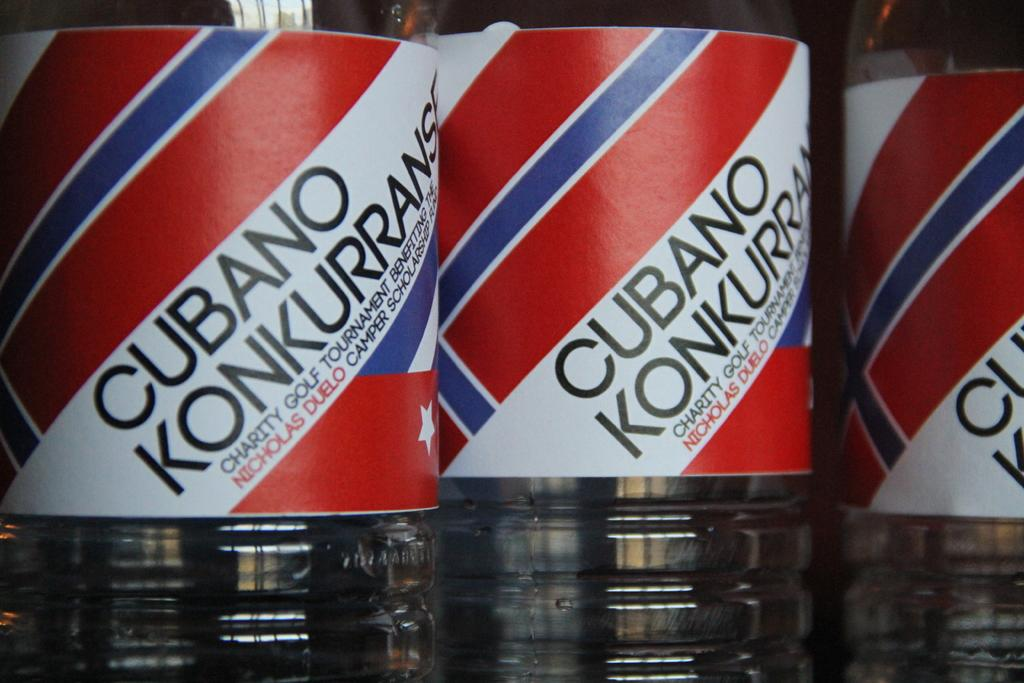<image>
Describe the image concisely. Three bottles of Cubano Konkurrans Charity Golf Tournament standing next to each other with red, white and blue colors. 